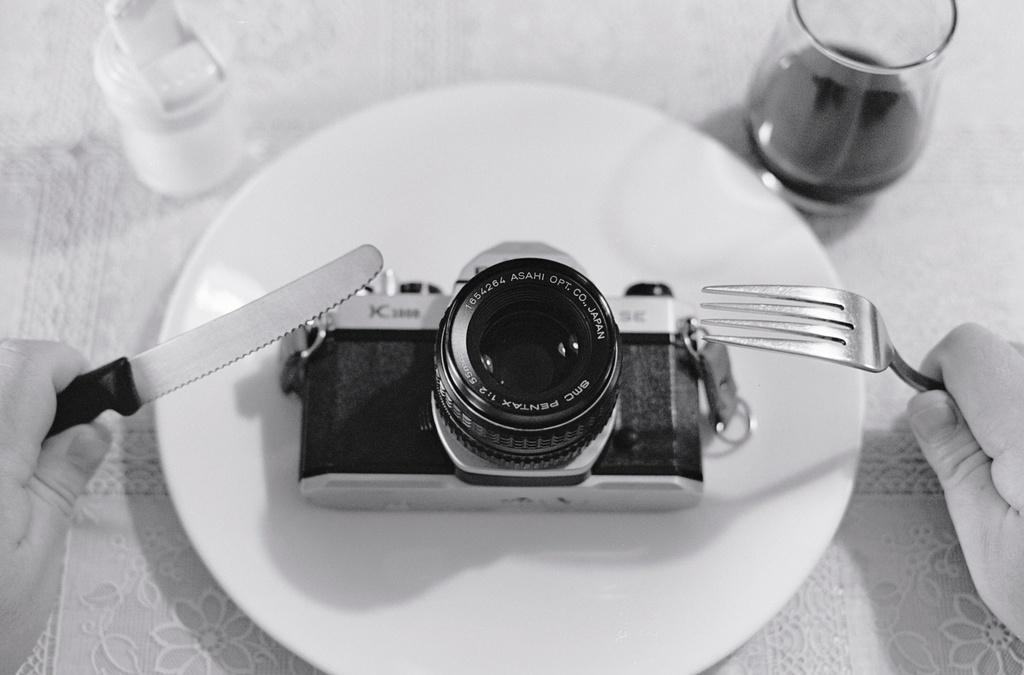How would you summarize this image in a sentence or two? In this image in the center there is a camera with some text written on it which is on the plate. On the right side of the plate there is a glass and on the left of the plate there is a bottle and on the top of the camera on the right side there is a fork and on the left side there is a knife which is holded by a person. 